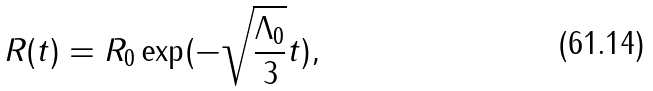Convert formula to latex. <formula><loc_0><loc_0><loc_500><loc_500>R ( t ) = R _ { 0 } \exp ( { - \sqrt { \frac { \Lambda _ { 0 } } { 3 } } t } ) ,</formula> 